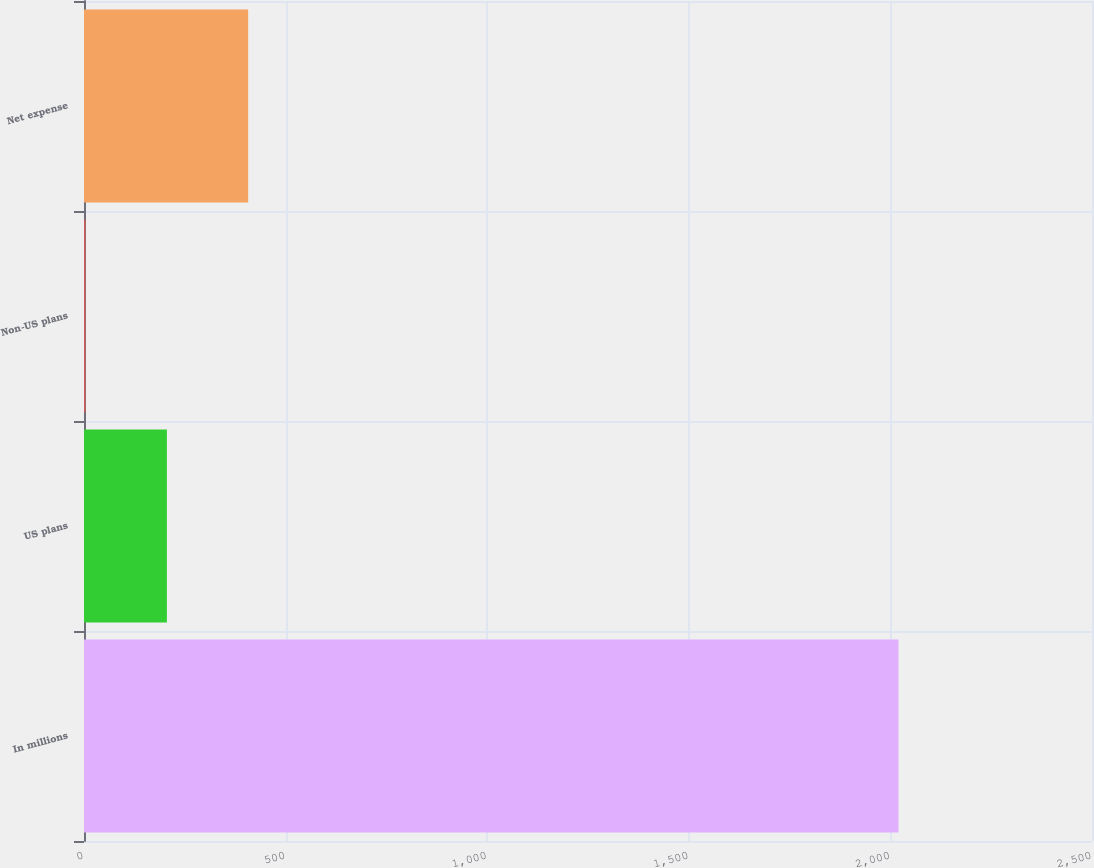Convert chart to OTSL. <chart><loc_0><loc_0><loc_500><loc_500><bar_chart><fcel>In millions<fcel>US plans<fcel>Non-US plans<fcel>Net expense<nl><fcel>2020<fcel>205.6<fcel>4<fcel>407.2<nl></chart> 